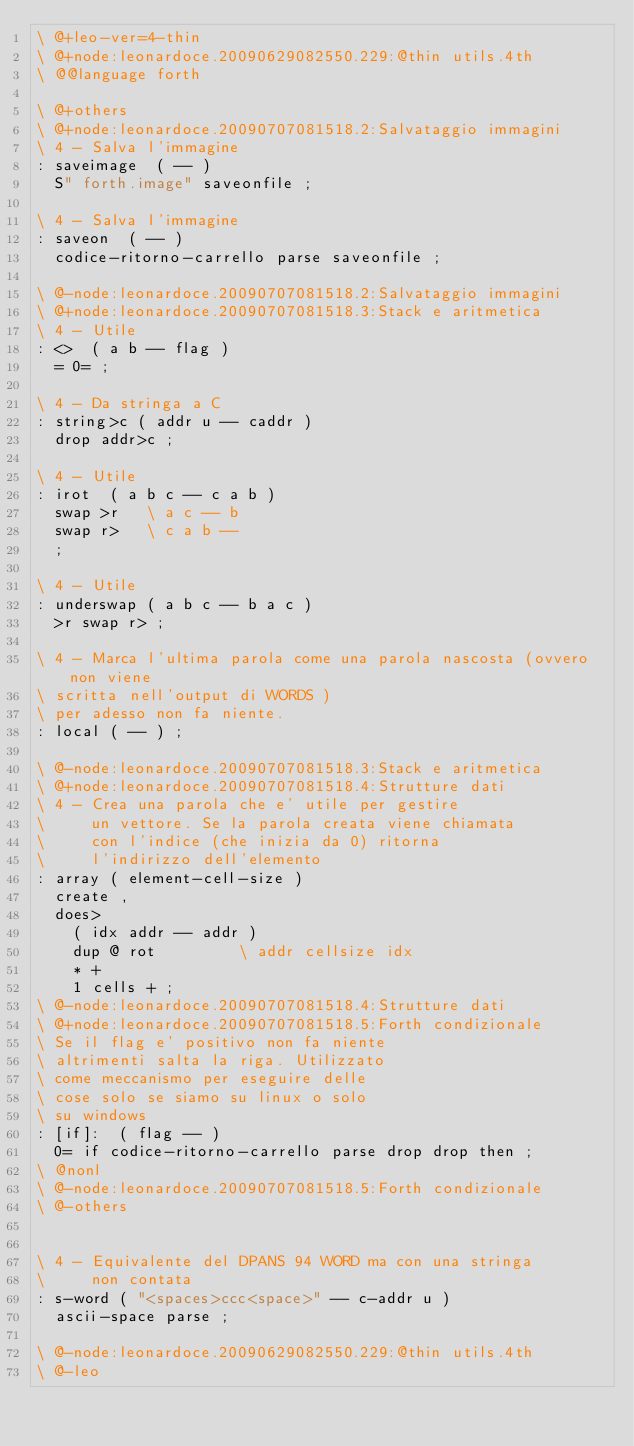<code> <loc_0><loc_0><loc_500><loc_500><_Forth_>\ @+leo-ver=4-thin
\ @+node:leonardoce.20090629082550.229:@thin utils.4th
\ @@language forth

\ @+others
\ @+node:leonardoce.20090707081518.2:Salvataggio immagini
\ 4 - Salva l'immagine
: saveimage  ( -- )
  S" forth.image" saveonfile ;

\ 4 - Salva l'immagine
: saveon  ( -- )
  codice-ritorno-carrello parse saveonfile ;

\ @-node:leonardoce.20090707081518.2:Salvataggio immagini
\ @+node:leonardoce.20090707081518.3:Stack e aritmetica
\ 4 - Utile
: <>  ( a b -- flag )
  = 0= ;

\ 4 - Da stringa a C
: string>c ( addr u -- caddr )
  drop addr>c ;

\ 4 - Utile
: irot  ( a b c -- c a b )
  swap >r   \ a c -- b
  swap r>   \ c a b --
  ;

\ 4 - Utile
: underswap ( a b c -- b a c )
  >r swap r> ;

\ 4 - Marca l'ultima parola come una parola nascosta (ovvero non viene
\ scritta nell'output di WORDS )
\ per adesso non fa niente.
: local ( -- ) ;

\ @-node:leonardoce.20090707081518.3:Stack e aritmetica
\ @+node:leonardoce.20090707081518.4:Strutture dati
\ 4 - Crea una parola che e' utile per gestire
\     un vettore. Se la parola creata viene chiamata
\     con l'indice (che inizia da 0) ritorna
\     l'indirizzo dell'elemento
: array ( element-cell-size )
  create , 
  does> 
    ( idx addr -- addr )
    dup @ rot         \ addr cellsize idx
    * + 
    1 cells + ;
\ @-node:leonardoce.20090707081518.4:Strutture dati
\ @+node:leonardoce.20090707081518.5:Forth condizionale
\ Se il flag e' positivo non fa niente
\ altrimenti salta la riga. Utilizzato
\ come meccanismo per eseguire delle 
\ cose solo se siamo su linux o solo
\ su windows
: [if]:  ( flag -- )
  0= if codice-ritorno-carrello parse drop drop then ;
\ @nonl
\ @-node:leonardoce.20090707081518.5:Forth condizionale
\ @-others


\ 4 - Equivalente del DPANS 94 WORD ma con una stringa
\     non contata
: s-word ( "<spaces>ccc<space>" -- c-addr u )
  ascii-space parse ;

\ @-node:leonardoce.20090629082550.229:@thin utils.4th
\ @-leo
</code> 